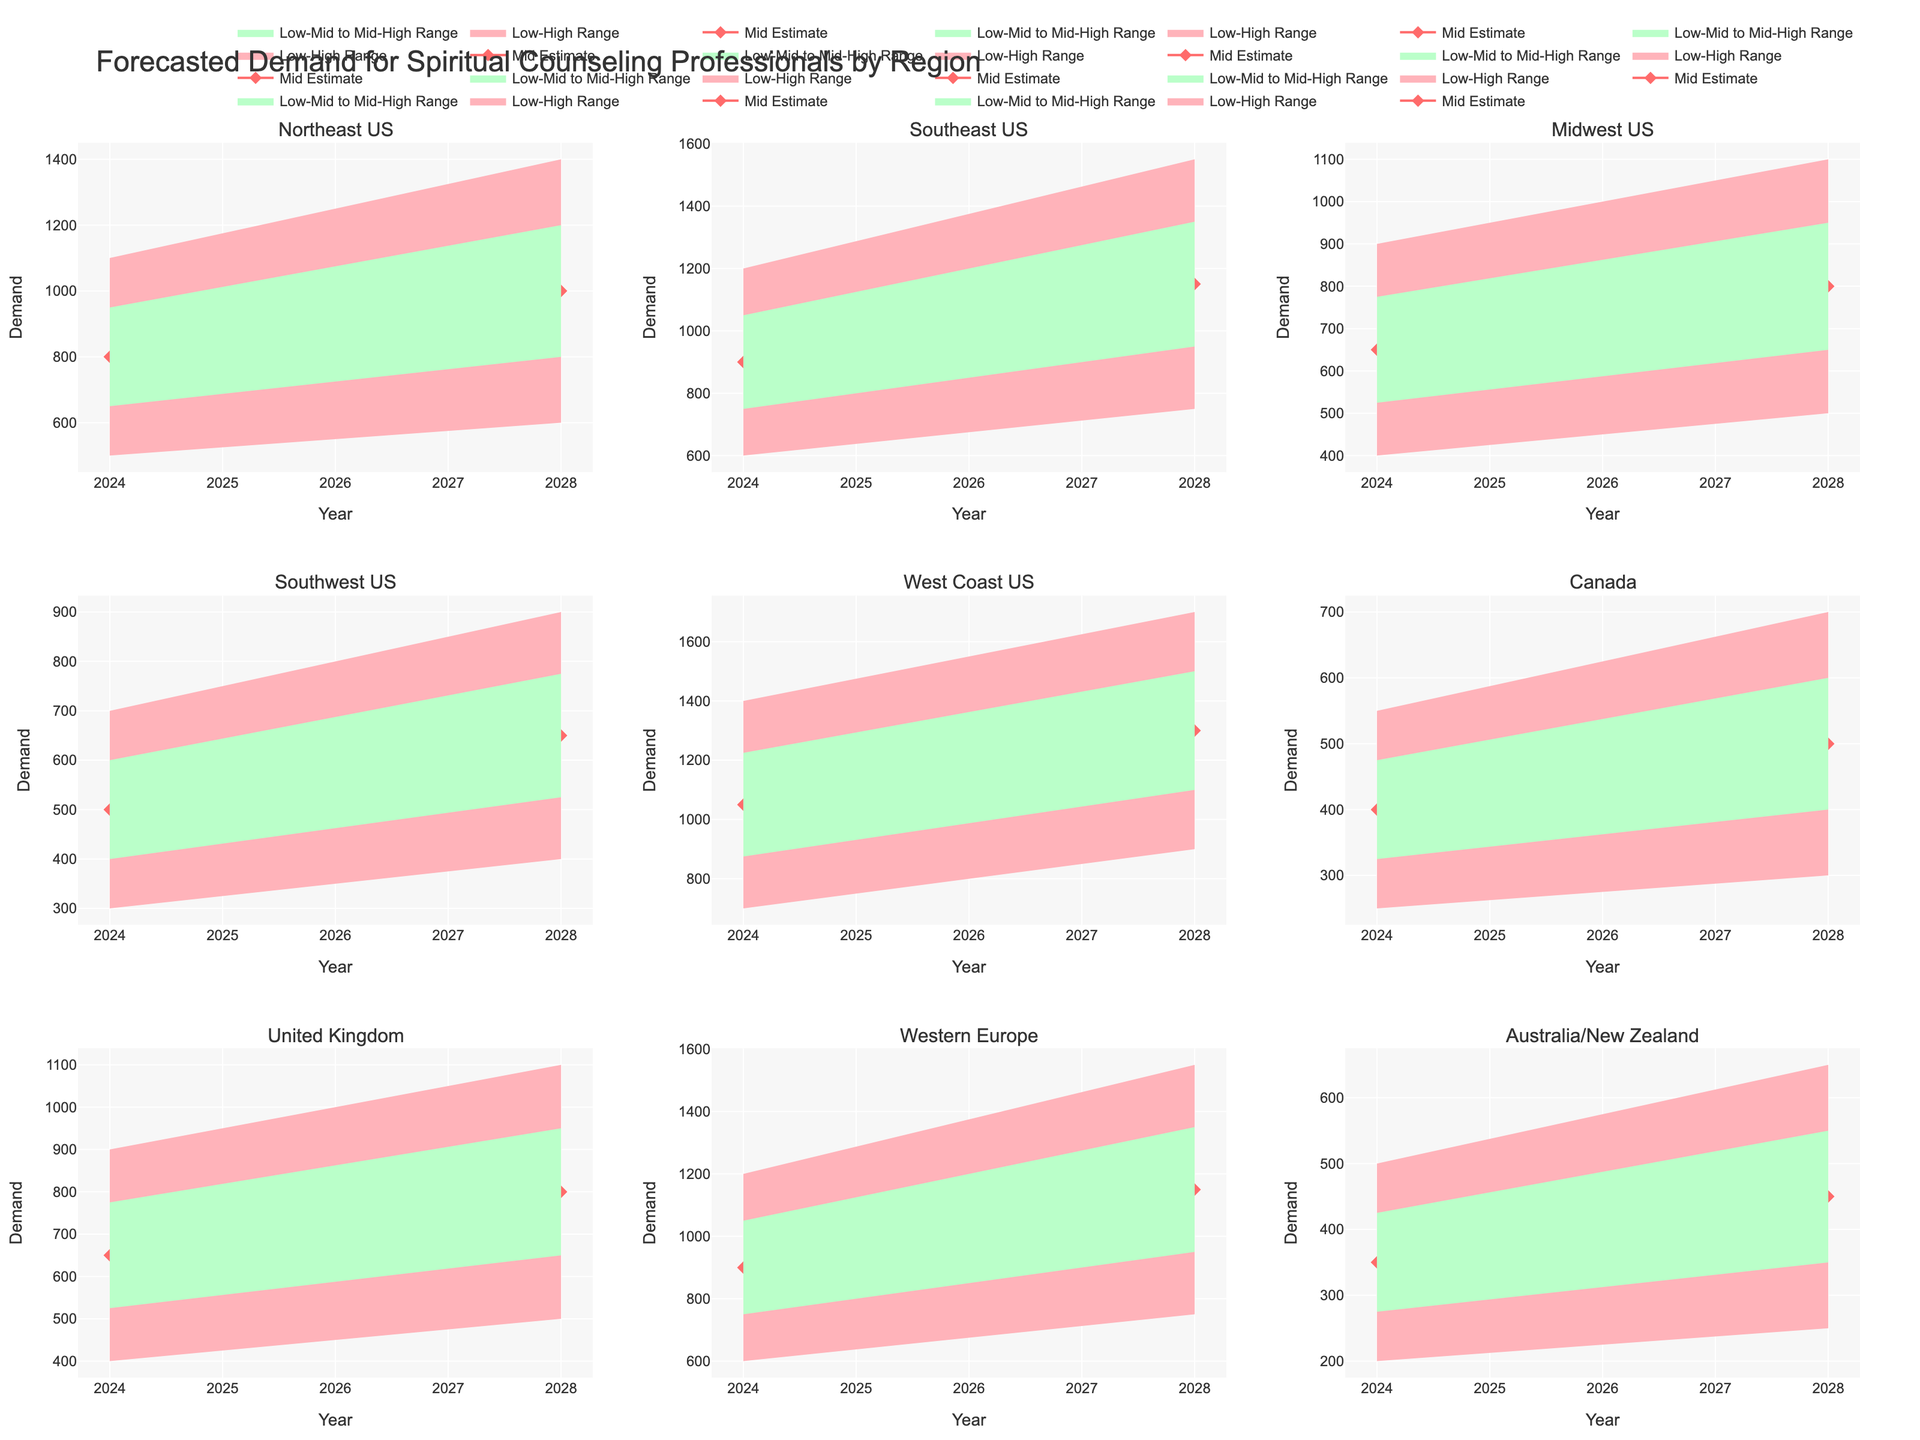What's the title of the figure? The title of the figure is presented at the top of the plot, typically in larger and bold font. In this case, it reads "Forecasted Demand for Spiritual Counseling Professionals by Region."
Answer: Forecasted Demand for Spiritual Counseling Professionals by Region Which region has the highest mid estimate for the year 2028? By looking at the Mid Estimate values for each region in 2028, we can see that the West Coast US has the highest mid estimate of 1300.
Answer: West Coast US What is the range of demand estimates for the Southeast US in the year 2024? To find the range of demand estimates, we look at the lowest estimate (600) and the highest estimate (1200) for the Southeast US in 2024. The range is from the lowest value to the highest value.
Answer: 600 to 1200 How many regions are included in the forecast? By counting the subplot titles, or the unique regions listed in the data, we can determine that there are 9 regions included in the forecast.
Answer: 9 Which region shows the greatest increase in mid estimate demand from 2024 to 2028? To determine the greatest increase, we find the difference in mid estimate demand for each region between 2024 and 2028. The West Coast US shows an increase from 1050 to 1300, which is a difference of 250. This is the greatest increase among all regions listed.
Answer: West Coast US Compare the low estimate for Canada in 2024 with the low estimate for the Midwest US in 2028. Which is higher and by how much? The low estimate for Canada in 2024 is 250, while the low estimate for the Midwest US in 2028 is 500. The Midwest US estimate is higher by 500 - 250 = 250.
Answer: Midwest US by 250 What is the average mid estimate demand for the Western Europe region across both years? To calculate the average, we sum the mid estimates for Western Europe in 2024 (900) and 2028 (1150), and then divide by 2. (900 + 1150) / 2 = 1025.
Answer: 1025 In 2028, which region's high estimate is closest to 1500? Comparing the high estimates for 2028, the West Coast US has a high estimate of 1700, which is the closest indicated region compared to 1500.
Answer: West Coast US What is the total high estimate demand for all regions in the year 2024? Summing the high estimate values for each region in 2024, we get: 1100 + 1200 + 900 + 700 + 1400 + 550 + 900 + 1200 + 500 = 8450.
Answer: 8450 